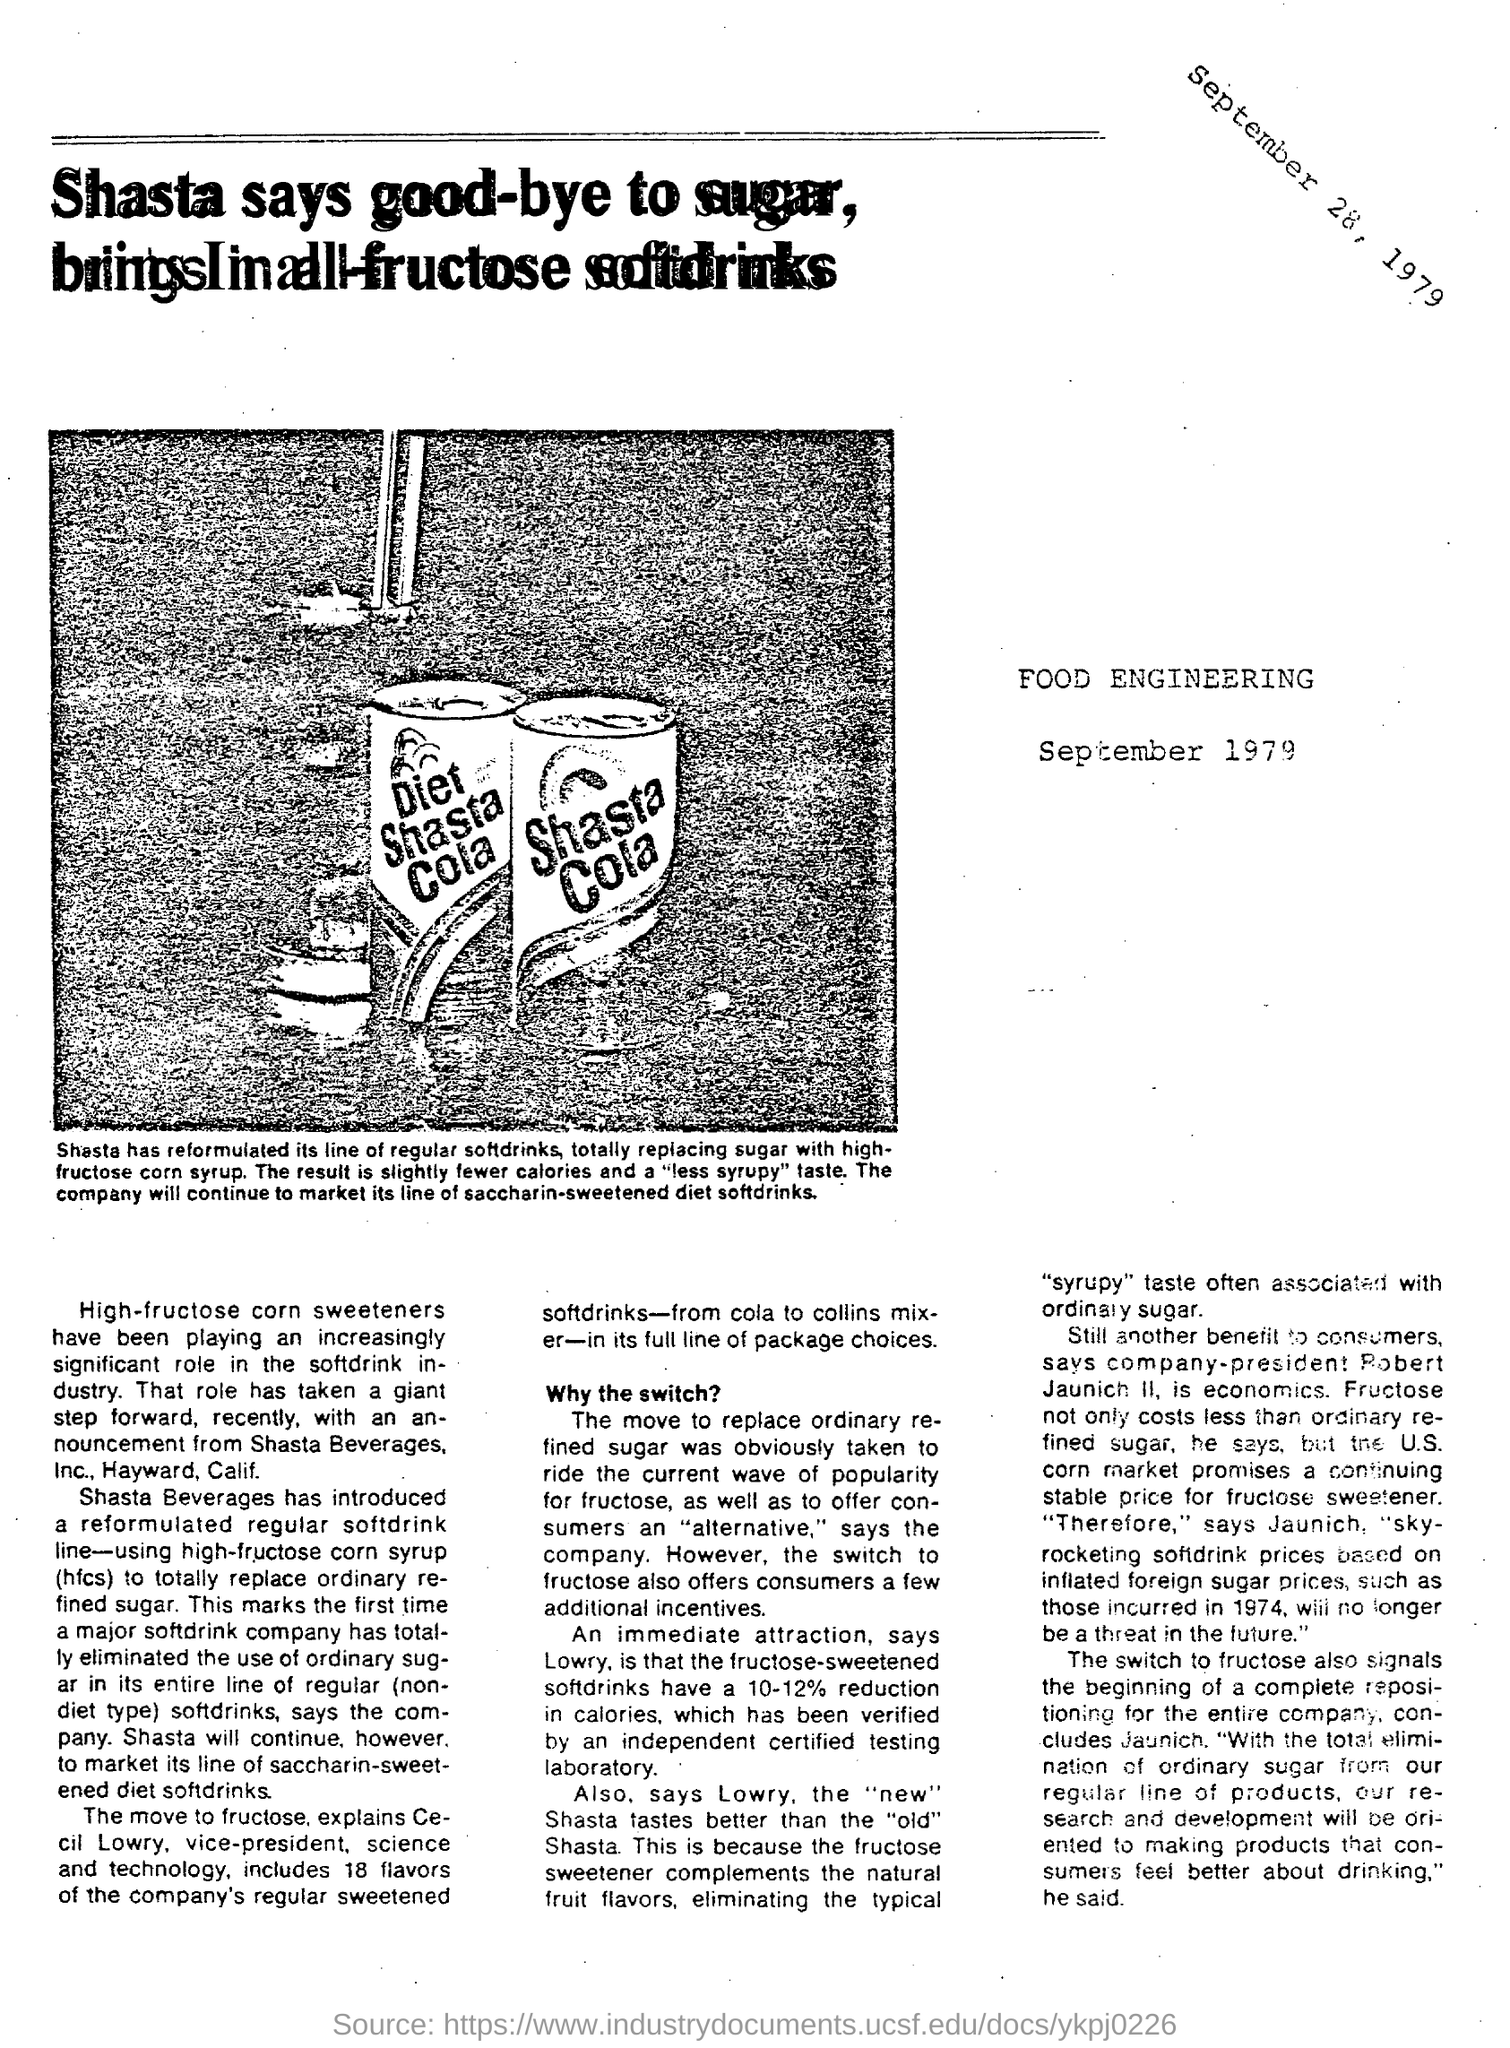What has been playing a significant role in soft drink industry?
Keep it short and to the point. High Fructose corn sweeteners. What is the percentage reduction in calories in the fructose sweetened soft drinks?
Give a very brief answer. 10-12%. 